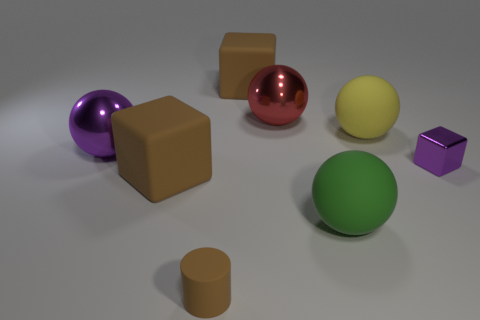Are there any other things that have the same size as the red metal thing? Yes, the yellow object appears to be of similar size to the red metal-looking object. Both share a spherical shape and relative dimensions, suggesting they could have an equivalent volume. 